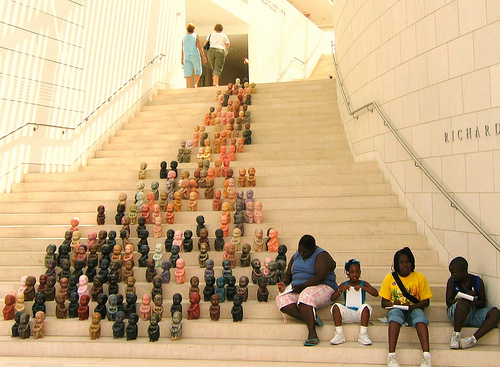<image>
Can you confirm if the lady is on the steps? Yes. Looking at the image, I can see the lady is positioned on top of the steps, with the steps providing support. 